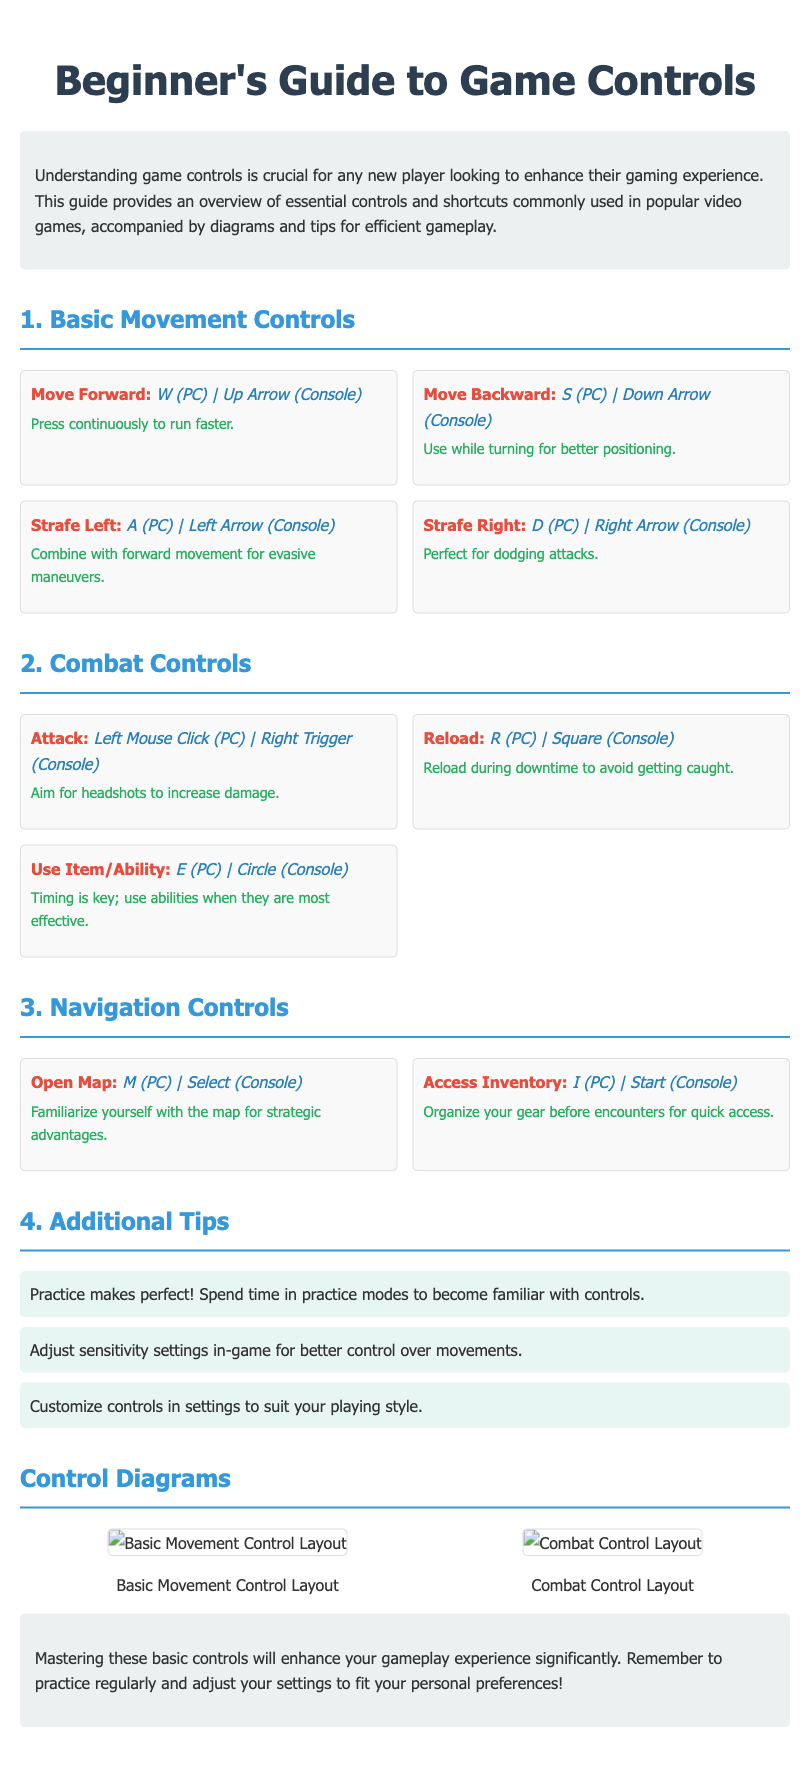What should you do while reloading? The document provides a tip related to reloading during downtime in the Combat Controls section.
Answer: Avoid getting caught Which key is used to access the inventory on PC? This information is found in the Navigation Controls section of the document under Access Inventory.
Answer: I (PC) What is the purpose of practicing in the game? This is stated under Additional Tips, where it emphasizes the importance of practice.
Answer: To become familiar with controls What should you focus on to increase damage when attacking? This reasoning is found in the Combat Controls section, under Attack.
Answer: Headshots How can you customize your gaming experience? The method for customization is included in the Additional Tips.
Answer: Adjusting controls in settings What is depicted in the first control diagram? The document specifies what the first control diagram showcases under Control Diagrams.
Answer: Basic Movement Control Layout 